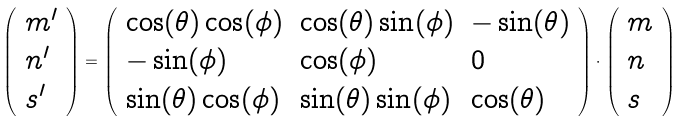<formula> <loc_0><loc_0><loc_500><loc_500>\left ( \begin{array} { l l } m ^ { \prime } \\ n ^ { \prime } \\ s ^ { \prime } \end{array} \right ) = \left ( \begin{array} { l l l } \cos ( \theta ) \cos ( \phi ) & \cos ( \theta ) \sin ( \phi ) & - \sin ( \theta ) \\ - \sin ( \phi ) & \cos ( \phi ) & 0 \\ \sin ( \theta ) \cos ( \phi ) & \sin ( \theta ) \sin ( \phi ) & \cos ( \theta ) \end{array} \right ) \cdot \left ( \begin{array} { l l } m \\ n \\ s \end{array} \right )</formula> 